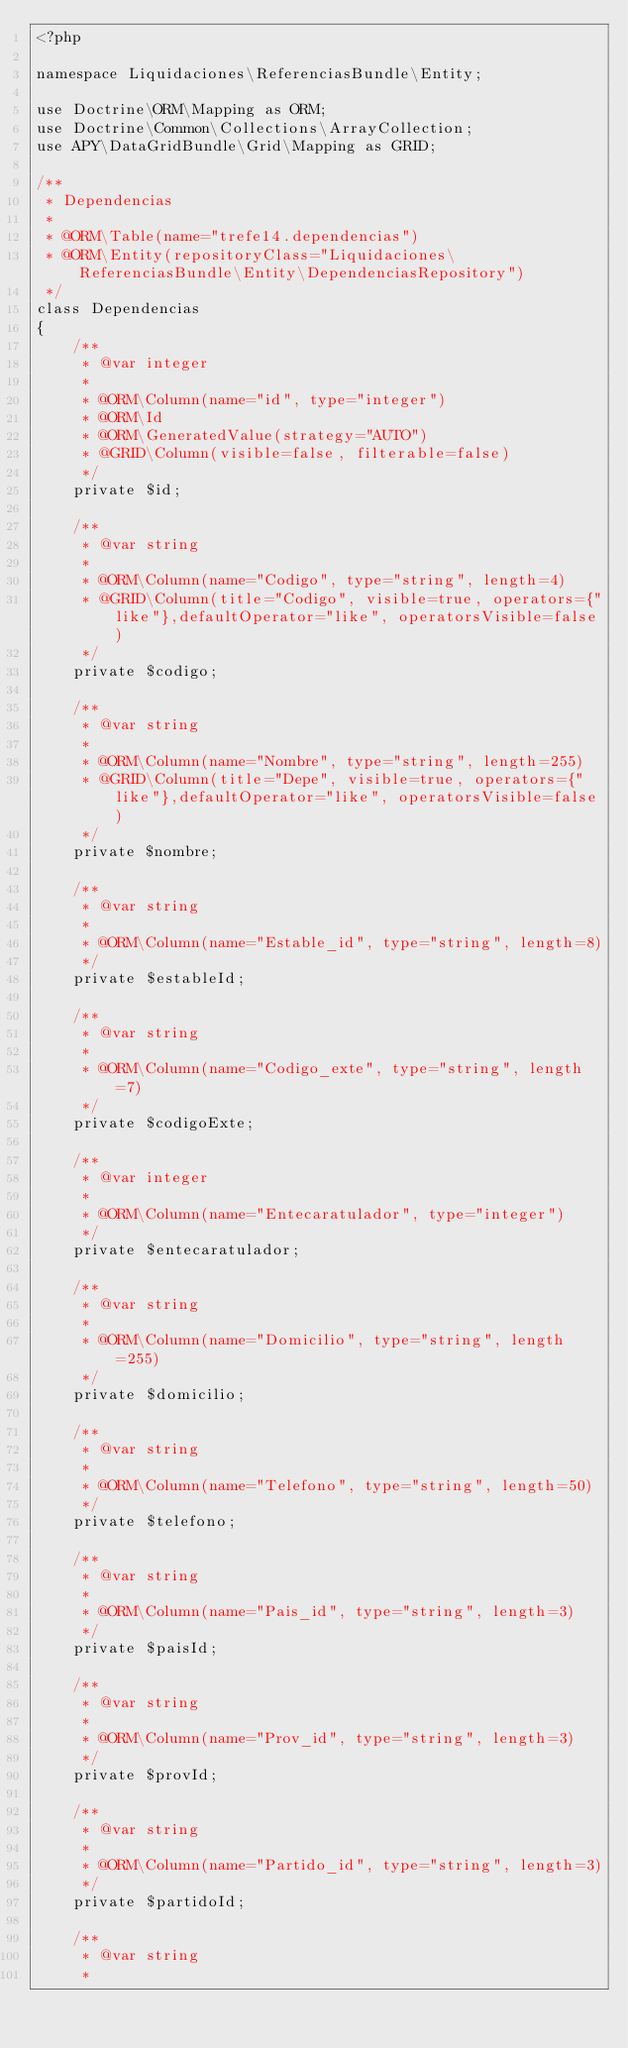<code> <loc_0><loc_0><loc_500><loc_500><_PHP_><?php

namespace Liquidaciones\ReferenciasBundle\Entity;

use Doctrine\ORM\Mapping as ORM;
use Doctrine\Common\Collections\ArrayCollection;
use APY\DataGridBundle\Grid\Mapping as GRID;

/**
 * Dependencias
 *
 * @ORM\Table(name="trefe14.dependencias")
 * @ORM\Entity(repositoryClass="Liquidaciones\ReferenciasBundle\Entity\DependenciasRepository")
 */
class Dependencias
{
    /**
     * @var integer
     *
     * @ORM\Column(name="id", type="integer")
     * @ORM\Id
     * @ORM\GeneratedValue(strategy="AUTO")
     * @GRID\Column(visible=false, filterable=false)
     */
    private $id;

    /**
     * @var string
     *
     * @ORM\Column(name="Codigo", type="string", length=4)
     * @GRID\Column(title="Codigo", visible=true, operators={"like"},defaultOperator="like", operatorsVisible=false)
     */
    private $codigo;

    /**
     * @var string
     *
     * @ORM\Column(name="Nombre", type="string", length=255)
     * @GRID\Column(title="Depe", visible=true, operators={"like"},defaultOperator="like", operatorsVisible=false)
     */
    private $nombre;

    /**
     * @var string
     *
     * @ORM\Column(name="Estable_id", type="string", length=8)
     */
    private $estableId;

    /**
     * @var string
     *
     * @ORM\Column(name="Codigo_exte", type="string", length=7)
     */
    private $codigoExte;

    /**
     * @var integer
     *
     * @ORM\Column(name="Entecaratulador", type="integer")
     */
    private $entecaratulador;

    /**
     * @var string
     *
     * @ORM\Column(name="Domicilio", type="string", length=255)
     */
    private $domicilio;

    /**
     * @var string
     *
     * @ORM\Column(name="Telefono", type="string", length=50)
     */
    private $telefono;

    /**
     * @var string
     *
     * @ORM\Column(name="Pais_id", type="string", length=3)
     */
    private $paisId;

    /**
     * @var string
     *
     * @ORM\Column(name="Prov_id", type="string", length=3)
     */
    private $provId;

    /**
     * @var string
     *
     * @ORM\Column(name="Partido_id", type="string", length=3)
     */
    private $partidoId;

    /**
     * @var string
     *</code> 